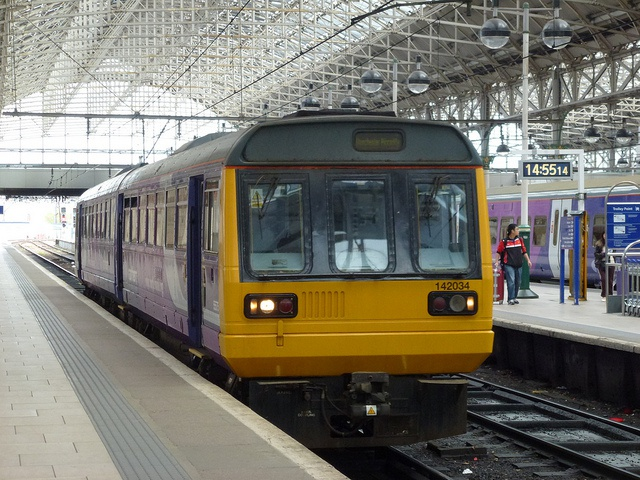Describe the objects in this image and their specific colors. I can see train in gray, black, olive, and darkgray tones, people in gray, black, blue, and navy tones, suitcase in gray, maroon, and darkgray tones, people in gray, black, and darkgray tones, and handbag in gray, black, purple, and maroon tones in this image. 